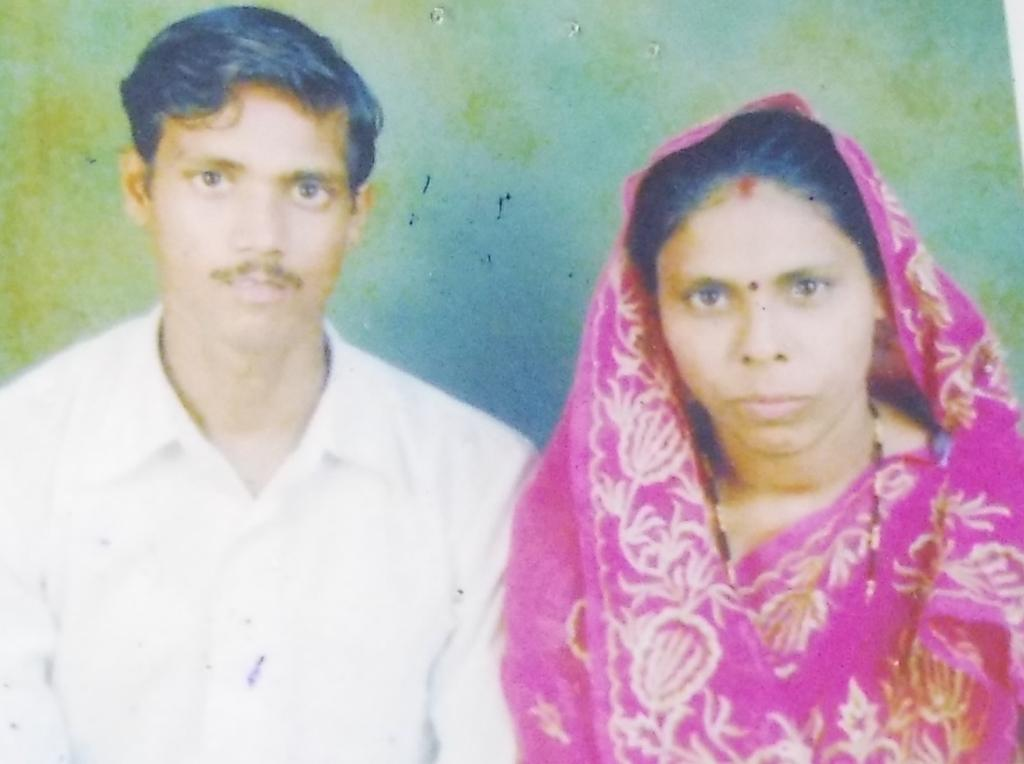Who are the people in the image? There is a couple in the picture. Where is the man positioned in the image? The man is on the left side of the image. What is the man wearing in the image? The man is wearing a white color shirt. Where is the woman positioned in the image? The woman is on the right side of the image. What is the woman wearing in the image? The woman is wearing a pink color saree. What type of cup can be seen on the train in the image? There is no cup or train present in the image; it features a couple with specific clothing and positioning. What are the couple learning in the image? The image does not depict any learning activity; it simply shows the couple's positioning and clothing. 